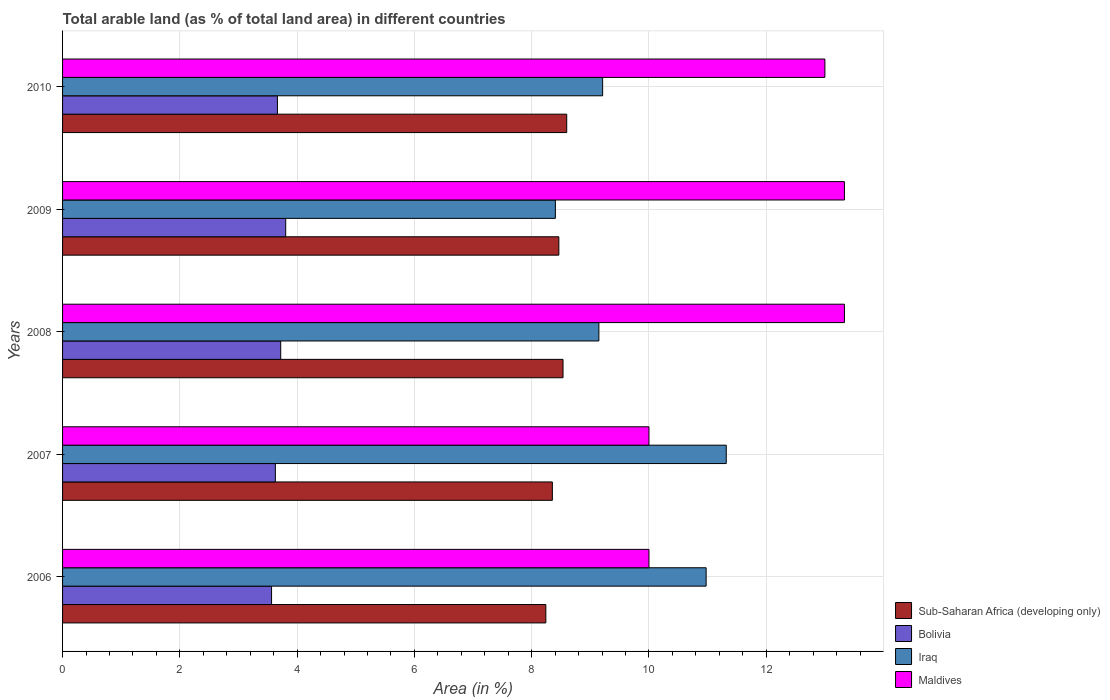How many different coloured bars are there?
Provide a short and direct response. 4. Are the number of bars on each tick of the Y-axis equal?
Make the answer very short. Yes. How many bars are there on the 2nd tick from the bottom?
Your answer should be very brief. 4. What is the label of the 1st group of bars from the top?
Offer a very short reply. 2010. In how many cases, is the number of bars for a given year not equal to the number of legend labels?
Your answer should be compact. 0. What is the percentage of arable land in Iraq in 2008?
Provide a short and direct response. 9.15. Across all years, what is the maximum percentage of arable land in Bolivia?
Provide a short and direct response. 3.81. Across all years, what is the minimum percentage of arable land in Maldives?
Provide a short and direct response. 10. In which year was the percentage of arable land in Sub-Saharan Africa (developing only) maximum?
Offer a very short reply. 2010. In which year was the percentage of arable land in Maldives minimum?
Give a very brief answer. 2006. What is the total percentage of arable land in Maldives in the graph?
Your answer should be compact. 59.67. What is the difference between the percentage of arable land in Iraq in 2009 and that in 2010?
Give a very brief answer. -0.81. What is the difference between the percentage of arable land in Maldives in 2006 and the percentage of arable land in Sub-Saharan Africa (developing only) in 2010?
Your answer should be very brief. 1.4. What is the average percentage of arable land in Iraq per year?
Offer a very short reply. 9.81. In the year 2007, what is the difference between the percentage of arable land in Maldives and percentage of arable land in Iraq?
Your response must be concise. -1.32. In how many years, is the percentage of arable land in Bolivia greater than 3.2 %?
Your answer should be very brief. 5. What is the ratio of the percentage of arable land in Iraq in 2006 to that in 2010?
Provide a succinct answer. 1.19. Is the percentage of arable land in Maldives in 2006 less than that in 2008?
Give a very brief answer. Yes. Is the difference between the percentage of arable land in Maldives in 2009 and 2010 greater than the difference between the percentage of arable land in Iraq in 2009 and 2010?
Your answer should be compact. Yes. What is the difference between the highest and the lowest percentage of arable land in Maldives?
Offer a very short reply. 3.33. In how many years, is the percentage of arable land in Bolivia greater than the average percentage of arable land in Bolivia taken over all years?
Keep it short and to the point. 2. Is it the case that in every year, the sum of the percentage of arable land in Bolivia and percentage of arable land in Sub-Saharan Africa (developing only) is greater than the sum of percentage of arable land in Maldives and percentage of arable land in Iraq?
Provide a short and direct response. No. What does the 3rd bar from the top in 2006 represents?
Offer a very short reply. Bolivia. What does the 4th bar from the bottom in 2008 represents?
Your answer should be compact. Maldives. How many years are there in the graph?
Your answer should be very brief. 5. What is the difference between two consecutive major ticks on the X-axis?
Offer a very short reply. 2. Are the values on the major ticks of X-axis written in scientific E-notation?
Give a very brief answer. No. Does the graph contain grids?
Provide a short and direct response. Yes. How many legend labels are there?
Ensure brevity in your answer.  4. What is the title of the graph?
Your answer should be very brief. Total arable land (as % of total land area) in different countries. Does "Djibouti" appear as one of the legend labels in the graph?
Give a very brief answer. No. What is the label or title of the X-axis?
Make the answer very short. Area (in %). What is the Area (in %) of Sub-Saharan Africa (developing only) in 2006?
Your response must be concise. 8.24. What is the Area (in %) of Bolivia in 2006?
Ensure brevity in your answer.  3.56. What is the Area (in %) in Iraq in 2006?
Make the answer very short. 10.97. What is the Area (in %) of Sub-Saharan Africa (developing only) in 2007?
Your answer should be very brief. 8.35. What is the Area (in %) of Bolivia in 2007?
Your response must be concise. 3.63. What is the Area (in %) of Iraq in 2007?
Give a very brief answer. 11.32. What is the Area (in %) of Maldives in 2007?
Ensure brevity in your answer.  10. What is the Area (in %) of Sub-Saharan Africa (developing only) in 2008?
Provide a short and direct response. 8.53. What is the Area (in %) of Bolivia in 2008?
Offer a very short reply. 3.72. What is the Area (in %) of Iraq in 2008?
Your response must be concise. 9.15. What is the Area (in %) in Maldives in 2008?
Offer a terse response. 13.33. What is the Area (in %) of Sub-Saharan Africa (developing only) in 2009?
Make the answer very short. 8.46. What is the Area (in %) in Bolivia in 2009?
Keep it short and to the point. 3.81. What is the Area (in %) in Iraq in 2009?
Give a very brief answer. 8.4. What is the Area (in %) in Maldives in 2009?
Make the answer very short. 13.33. What is the Area (in %) in Sub-Saharan Africa (developing only) in 2010?
Your answer should be compact. 8.6. What is the Area (in %) in Bolivia in 2010?
Provide a short and direct response. 3.66. What is the Area (in %) of Iraq in 2010?
Make the answer very short. 9.21. What is the Area (in %) in Maldives in 2010?
Keep it short and to the point. 13. Across all years, what is the maximum Area (in %) in Sub-Saharan Africa (developing only)?
Make the answer very short. 8.6. Across all years, what is the maximum Area (in %) in Bolivia?
Your answer should be very brief. 3.81. Across all years, what is the maximum Area (in %) in Iraq?
Make the answer very short. 11.32. Across all years, what is the maximum Area (in %) in Maldives?
Provide a short and direct response. 13.33. Across all years, what is the minimum Area (in %) in Sub-Saharan Africa (developing only)?
Offer a very short reply. 8.24. Across all years, what is the minimum Area (in %) in Bolivia?
Make the answer very short. 3.56. Across all years, what is the minimum Area (in %) of Iraq?
Provide a succinct answer. 8.4. Across all years, what is the minimum Area (in %) in Maldives?
Your answer should be compact. 10. What is the total Area (in %) in Sub-Saharan Africa (developing only) in the graph?
Your answer should be compact. 42.19. What is the total Area (in %) of Bolivia in the graph?
Make the answer very short. 18.38. What is the total Area (in %) in Iraq in the graph?
Your answer should be compact. 49.05. What is the total Area (in %) in Maldives in the graph?
Provide a succinct answer. 59.67. What is the difference between the Area (in %) in Sub-Saharan Africa (developing only) in 2006 and that in 2007?
Ensure brevity in your answer.  -0.11. What is the difference between the Area (in %) of Bolivia in 2006 and that in 2007?
Offer a very short reply. -0.06. What is the difference between the Area (in %) of Iraq in 2006 and that in 2007?
Keep it short and to the point. -0.34. What is the difference between the Area (in %) in Sub-Saharan Africa (developing only) in 2006 and that in 2008?
Keep it short and to the point. -0.29. What is the difference between the Area (in %) in Bolivia in 2006 and that in 2008?
Offer a very short reply. -0.16. What is the difference between the Area (in %) in Iraq in 2006 and that in 2008?
Your response must be concise. 1.83. What is the difference between the Area (in %) of Sub-Saharan Africa (developing only) in 2006 and that in 2009?
Make the answer very short. -0.22. What is the difference between the Area (in %) of Bolivia in 2006 and that in 2009?
Your response must be concise. -0.24. What is the difference between the Area (in %) in Iraq in 2006 and that in 2009?
Keep it short and to the point. 2.57. What is the difference between the Area (in %) of Maldives in 2006 and that in 2009?
Your response must be concise. -3.33. What is the difference between the Area (in %) of Sub-Saharan Africa (developing only) in 2006 and that in 2010?
Offer a very short reply. -0.36. What is the difference between the Area (in %) in Bolivia in 2006 and that in 2010?
Your response must be concise. -0.1. What is the difference between the Area (in %) of Iraq in 2006 and that in 2010?
Give a very brief answer. 1.76. What is the difference between the Area (in %) of Maldives in 2006 and that in 2010?
Offer a very short reply. -3. What is the difference between the Area (in %) in Sub-Saharan Africa (developing only) in 2007 and that in 2008?
Offer a very short reply. -0.18. What is the difference between the Area (in %) in Bolivia in 2007 and that in 2008?
Provide a short and direct response. -0.09. What is the difference between the Area (in %) in Iraq in 2007 and that in 2008?
Your answer should be compact. 2.17. What is the difference between the Area (in %) in Maldives in 2007 and that in 2008?
Offer a terse response. -3.33. What is the difference between the Area (in %) in Sub-Saharan Africa (developing only) in 2007 and that in 2009?
Provide a succinct answer. -0.11. What is the difference between the Area (in %) in Bolivia in 2007 and that in 2009?
Your answer should be very brief. -0.18. What is the difference between the Area (in %) of Iraq in 2007 and that in 2009?
Keep it short and to the point. 2.91. What is the difference between the Area (in %) of Sub-Saharan Africa (developing only) in 2007 and that in 2010?
Provide a short and direct response. -0.24. What is the difference between the Area (in %) in Bolivia in 2007 and that in 2010?
Keep it short and to the point. -0.04. What is the difference between the Area (in %) of Iraq in 2007 and that in 2010?
Ensure brevity in your answer.  2.11. What is the difference between the Area (in %) of Sub-Saharan Africa (developing only) in 2008 and that in 2009?
Ensure brevity in your answer.  0.07. What is the difference between the Area (in %) of Bolivia in 2008 and that in 2009?
Provide a succinct answer. -0.08. What is the difference between the Area (in %) of Iraq in 2008 and that in 2009?
Your answer should be very brief. 0.74. What is the difference between the Area (in %) of Sub-Saharan Africa (developing only) in 2008 and that in 2010?
Offer a terse response. -0.06. What is the difference between the Area (in %) of Bolivia in 2008 and that in 2010?
Offer a terse response. 0.06. What is the difference between the Area (in %) of Iraq in 2008 and that in 2010?
Offer a very short reply. -0.06. What is the difference between the Area (in %) of Sub-Saharan Africa (developing only) in 2009 and that in 2010?
Ensure brevity in your answer.  -0.13. What is the difference between the Area (in %) of Bolivia in 2009 and that in 2010?
Keep it short and to the point. 0.14. What is the difference between the Area (in %) of Iraq in 2009 and that in 2010?
Offer a very short reply. -0.81. What is the difference between the Area (in %) of Maldives in 2009 and that in 2010?
Provide a succinct answer. 0.33. What is the difference between the Area (in %) in Sub-Saharan Africa (developing only) in 2006 and the Area (in %) in Bolivia in 2007?
Provide a short and direct response. 4.61. What is the difference between the Area (in %) in Sub-Saharan Africa (developing only) in 2006 and the Area (in %) in Iraq in 2007?
Provide a succinct answer. -3.08. What is the difference between the Area (in %) of Sub-Saharan Africa (developing only) in 2006 and the Area (in %) of Maldives in 2007?
Your answer should be very brief. -1.76. What is the difference between the Area (in %) in Bolivia in 2006 and the Area (in %) in Iraq in 2007?
Ensure brevity in your answer.  -7.75. What is the difference between the Area (in %) in Bolivia in 2006 and the Area (in %) in Maldives in 2007?
Offer a terse response. -6.44. What is the difference between the Area (in %) in Iraq in 2006 and the Area (in %) in Maldives in 2007?
Keep it short and to the point. 0.97. What is the difference between the Area (in %) in Sub-Saharan Africa (developing only) in 2006 and the Area (in %) in Bolivia in 2008?
Your answer should be compact. 4.52. What is the difference between the Area (in %) of Sub-Saharan Africa (developing only) in 2006 and the Area (in %) of Iraq in 2008?
Offer a terse response. -0.9. What is the difference between the Area (in %) of Sub-Saharan Africa (developing only) in 2006 and the Area (in %) of Maldives in 2008?
Offer a very short reply. -5.09. What is the difference between the Area (in %) in Bolivia in 2006 and the Area (in %) in Iraq in 2008?
Offer a very short reply. -5.58. What is the difference between the Area (in %) in Bolivia in 2006 and the Area (in %) in Maldives in 2008?
Provide a short and direct response. -9.77. What is the difference between the Area (in %) of Iraq in 2006 and the Area (in %) of Maldives in 2008?
Offer a very short reply. -2.36. What is the difference between the Area (in %) of Sub-Saharan Africa (developing only) in 2006 and the Area (in %) of Bolivia in 2009?
Your response must be concise. 4.44. What is the difference between the Area (in %) in Sub-Saharan Africa (developing only) in 2006 and the Area (in %) in Iraq in 2009?
Your answer should be compact. -0.16. What is the difference between the Area (in %) of Sub-Saharan Africa (developing only) in 2006 and the Area (in %) of Maldives in 2009?
Keep it short and to the point. -5.09. What is the difference between the Area (in %) in Bolivia in 2006 and the Area (in %) in Iraq in 2009?
Ensure brevity in your answer.  -4.84. What is the difference between the Area (in %) of Bolivia in 2006 and the Area (in %) of Maldives in 2009?
Keep it short and to the point. -9.77. What is the difference between the Area (in %) of Iraq in 2006 and the Area (in %) of Maldives in 2009?
Your answer should be compact. -2.36. What is the difference between the Area (in %) in Sub-Saharan Africa (developing only) in 2006 and the Area (in %) in Bolivia in 2010?
Provide a succinct answer. 4.58. What is the difference between the Area (in %) of Sub-Saharan Africa (developing only) in 2006 and the Area (in %) of Iraq in 2010?
Keep it short and to the point. -0.97. What is the difference between the Area (in %) of Sub-Saharan Africa (developing only) in 2006 and the Area (in %) of Maldives in 2010?
Make the answer very short. -4.76. What is the difference between the Area (in %) in Bolivia in 2006 and the Area (in %) in Iraq in 2010?
Your response must be concise. -5.65. What is the difference between the Area (in %) of Bolivia in 2006 and the Area (in %) of Maldives in 2010?
Your answer should be very brief. -9.44. What is the difference between the Area (in %) in Iraq in 2006 and the Area (in %) in Maldives in 2010?
Your response must be concise. -2.03. What is the difference between the Area (in %) of Sub-Saharan Africa (developing only) in 2007 and the Area (in %) of Bolivia in 2008?
Your answer should be very brief. 4.63. What is the difference between the Area (in %) of Sub-Saharan Africa (developing only) in 2007 and the Area (in %) of Iraq in 2008?
Ensure brevity in your answer.  -0.79. What is the difference between the Area (in %) of Sub-Saharan Africa (developing only) in 2007 and the Area (in %) of Maldives in 2008?
Offer a terse response. -4.98. What is the difference between the Area (in %) in Bolivia in 2007 and the Area (in %) in Iraq in 2008?
Give a very brief answer. -5.52. What is the difference between the Area (in %) of Bolivia in 2007 and the Area (in %) of Maldives in 2008?
Provide a succinct answer. -9.7. What is the difference between the Area (in %) in Iraq in 2007 and the Area (in %) in Maldives in 2008?
Your answer should be compact. -2.02. What is the difference between the Area (in %) of Sub-Saharan Africa (developing only) in 2007 and the Area (in %) of Bolivia in 2009?
Ensure brevity in your answer.  4.55. What is the difference between the Area (in %) in Sub-Saharan Africa (developing only) in 2007 and the Area (in %) in Iraq in 2009?
Ensure brevity in your answer.  -0.05. What is the difference between the Area (in %) of Sub-Saharan Africa (developing only) in 2007 and the Area (in %) of Maldives in 2009?
Keep it short and to the point. -4.98. What is the difference between the Area (in %) in Bolivia in 2007 and the Area (in %) in Iraq in 2009?
Provide a succinct answer. -4.78. What is the difference between the Area (in %) of Bolivia in 2007 and the Area (in %) of Maldives in 2009?
Your answer should be very brief. -9.7. What is the difference between the Area (in %) of Iraq in 2007 and the Area (in %) of Maldives in 2009?
Keep it short and to the point. -2.02. What is the difference between the Area (in %) of Sub-Saharan Africa (developing only) in 2007 and the Area (in %) of Bolivia in 2010?
Your answer should be very brief. 4.69. What is the difference between the Area (in %) in Sub-Saharan Africa (developing only) in 2007 and the Area (in %) in Iraq in 2010?
Ensure brevity in your answer.  -0.86. What is the difference between the Area (in %) in Sub-Saharan Africa (developing only) in 2007 and the Area (in %) in Maldives in 2010?
Provide a succinct answer. -4.65. What is the difference between the Area (in %) of Bolivia in 2007 and the Area (in %) of Iraq in 2010?
Your response must be concise. -5.58. What is the difference between the Area (in %) of Bolivia in 2007 and the Area (in %) of Maldives in 2010?
Your answer should be very brief. -9.37. What is the difference between the Area (in %) in Iraq in 2007 and the Area (in %) in Maldives in 2010?
Your answer should be very brief. -1.68. What is the difference between the Area (in %) in Sub-Saharan Africa (developing only) in 2008 and the Area (in %) in Bolivia in 2009?
Offer a terse response. 4.73. What is the difference between the Area (in %) in Sub-Saharan Africa (developing only) in 2008 and the Area (in %) in Iraq in 2009?
Your answer should be compact. 0.13. What is the difference between the Area (in %) of Sub-Saharan Africa (developing only) in 2008 and the Area (in %) of Maldives in 2009?
Your answer should be very brief. -4.8. What is the difference between the Area (in %) of Bolivia in 2008 and the Area (in %) of Iraq in 2009?
Your answer should be compact. -4.68. What is the difference between the Area (in %) in Bolivia in 2008 and the Area (in %) in Maldives in 2009?
Offer a terse response. -9.61. What is the difference between the Area (in %) in Iraq in 2008 and the Area (in %) in Maldives in 2009?
Offer a terse response. -4.19. What is the difference between the Area (in %) in Sub-Saharan Africa (developing only) in 2008 and the Area (in %) in Bolivia in 2010?
Keep it short and to the point. 4.87. What is the difference between the Area (in %) of Sub-Saharan Africa (developing only) in 2008 and the Area (in %) of Iraq in 2010?
Offer a terse response. -0.68. What is the difference between the Area (in %) of Sub-Saharan Africa (developing only) in 2008 and the Area (in %) of Maldives in 2010?
Provide a succinct answer. -4.47. What is the difference between the Area (in %) in Bolivia in 2008 and the Area (in %) in Iraq in 2010?
Provide a short and direct response. -5.49. What is the difference between the Area (in %) of Bolivia in 2008 and the Area (in %) of Maldives in 2010?
Your response must be concise. -9.28. What is the difference between the Area (in %) of Iraq in 2008 and the Area (in %) of Maldives in 2010?
Provide a succinct answer. -3.85. What is the difference between the Area (in %) in Sub-Saharan Africa (developing only) in 2009 and the Area (in %) in Bolivia in 2010?
Your answer should be very brief. 4.8. What is the difference between the Area (in %) of Sub-Saharan Africa (developing only) in 2009 and the Area (in %) of Iraq in 2010?
Your answer should be very brief. -0.75. What is the difference between the Area (in %) of Sub-Saharan Africa (developing only) in 2009 and the Area (in %) of Maldives in 2010?
Keep it short and to the point. -4.54. What is the difference between the Area (in %) in Bolivia in 2009 and the Area (in %) in Iraq in 2010?
Provide a succinct answer. -5.4. What is the difference between the Area (in %) in Bolivia in 2009 and the Area (in %) in Maldives in 2010?
Keep it short and to the point. -9.2. What is the difference between the Area (in %) in Iraq in 2009 and the Area (in %) in Maldives in 2010?
Keep it short and to the point. -4.6. What is the average Area (in %) of Sub-Saharan Africa (developing only) per year?
Give a very brief answer. 8.44. What is the average Area (in %) of Bolivia per year?
Ensure brevity in your answer.  3.68. What is the average Area (in %) in Iraq per year?
Provide a succinct answer. 9.81. What is the average Area (in %) in Maldives per year?
Offer a very short reply. 11.93. In the year 2006, what is the difference between the Area (in %) in Sub-Saharan Africa (developing only) and Area (in %) in Bolivia?
Provide a succinct answer. 4.68. In the year 2006, what is the difference between the Area (in %) of Sub-Saharan Africa (developing only) and Area (in %) of Iraq?
Your answer should be compact. -2.73. In the year 2006, what is the difference between the Area (in %) of Sub-Saharan Africa (developing only) and Area (in %) of Maldives?
Your answer should be compact. -1.76. In the year 2006, what is the difference between the Area (in %) of Bolivia and Area (in %) of Iraq?
Your answer should be compact. -7.41. In the year 2006, what is the difference between the Area (in %) in Bolivia and Area (in %) in Maldives?
Offer a very short reply. -6.44. In the year 2006, what is the difference between the Area (in %) of Iraq and Area (in %) of Maldives?
Your answer should be very brief. 0.97. In the year 2007, what is the difference between the Area (in %) in Sub-Saharan Africa (developing only) and Area (in %) in Bolivia?
Provide a succinct answer. 4.72. In the year 2007, what is the difference between the Area (in %) in Sub-Saharan Africa (developing only) and Area (in %) in Iraq?
Provide a succinct answer. -2.97. In the year 2007, what is the difference between the Area (in %) in Sub-Saharan Africa (developing only) and Area (in %) in Maldives?
Your answer should be very brief. -1.65. In the year 2007, what is the difference between the Area (in %) in Bolivia and Area (in %) in Iraq?
Ensure brevity in your answer.  -7.69. In the year 2007, what is the difference between the Area (in %) in Bolivia and Area (in %) in Maldives?
Your response must be concise. -6.37. In the year 2007, what is the difference between the Area (in %) of Iraq and Area (in %) of Maldives?
Offer a terse response. 1.32. In the year 2008, what is the difference between the Area (in %) of Sub-Saharan Africa (developing only) and Area (in %) of Bolivia?
Your answer should be compact. 4.81. In the year 2008, what is the difference between the Area (in %) in Sub-Saharan Africa (developing only) and Area (in %) in Iraq?
Your response must be concise. -0.61. In the year 2008, what is the difference between the Area (in %) in Sub-Saharan Africa (developing only) and Area (in %) in Maldives?
Your response must be concise. -4.8. In the year 2008, what is the difference between the Area (in %) of Bolivia and Area (in %) of Iraq?
Make the answer very short. -5.43. In the year 2008, what is the difference between the Area (in %) of Bolivia and Area (in %) of Maldives?
Your answer should be compact. -9.61. In the year 2008, what is the difference between the Area (in %) in Iraq and Area (in %) in Maldives?
Your response must be concise. -4.19. In the year 2009, what is the difference between the Area (in %) of Sub-Saharan Africa (developing only) and Area (in %) of Bolivia?
Ensure brevity in your answer.  4.66. In the year 2009, what is the difference between the Area (in %) in Sub-Saharan Africa (developing only) and Area (in %) in Iraq?
Provide a succinct answer. 0.06. In the year 2009, what is the difference between the Area (in %) of Sub-Saharan Africa (developing only) and Area (in %) of Maldives?
Offer a terse response. -4.87. In the year 2009, what is the difference between the Area (in %) of Bolivia and Area (in %) of Iraq?
Provide a short and direct response. -4.6. In the year 2009, what is the difference between the Area (in %) of Bolivia and Area (in %) of Maldives?
Offer a very short reply. -9.53. In the year 2009, what is the difference between the Area (in %) in Iraq and Area (in %) in Maldives?
Your answer should be very brief. -4.93. In the year 2010, what is the difference between the Area (in %) in Sub-Saharan Africa (developing only) and Area (in %) in Bolivia?
Give a very brief answer. 4.93. In the year 2010, what is the difference between the Area (in %) in Sub-Saharan Africa (developing only) and Area (in %) in Iraq?
Provide a short and direct response. -0.61. In the year 2010, what is the difference between the Area (in %) in Sub-Saharan Africa (developing only) and Area (in %) in Maldives?
Your response must be concise. -4.4. In the year 2010, what is the difference between the Area (in %) of Bolivia and Area (in %) of Iraq?
Keep it short and to the point. -5.55. In the year 2010, what is the difference between the Area (in %) in Bolivia and Area (in %) in Maldives?
Keep it short and to the point. -9.34. In the year 2010, what is the difference between the Area (in %) in Iraq and Area (in %) in Maldives?
Provide a short and direct response. -3.79. What is the ratio of the Area (in %) in Sub-Saharan Africa (developing only) in 2006 to that in 2007?
Give a very brief answer. 0.99. What is the ratio of the Area (in %) of Bolivia in 2006 to that in 2007?
Offer a terse response. 0.98. What is the ratio of the Area (in %) in Iraq in 2006 to that in 2007?
Provide a succinct answer. 0.97. What is the ratio of the Area (in %) of Maldives in 2006 to that in 2007?
Ensure brevity in your answer.  1. What is the ratio of the Area (in %) in Sub-Saharan Africa (developing only) in 2006 to that in 2008?
Ensure brevity in your answer.  0.97. What is the ratio of the Area (in %) in Bolivia in 2006 to that in 2008?
Give a very brief answer. 0.96. What is the ratio of the Area (in %) of Iraq in 2006 to that in 2008?
Provide a short and direct response. 1.2. What is the ratio of the Area (in %) in Sub-Saharan Africa (developing only) in 2006 to that in 2009?
Offer a very short reply. 0.97. What is the ratio of the Area (in %) of Bolivia in 2006 to that in 2009?
Provide a short and direct response. 0.94. What is the ratio of the Area (in %) in Iraq in 2006 to that in 2009?
Provide a short and direct response. 1.31. What is the ratio of the Area (in %) of Maldives in 2006 to that in 2009?
Your response must be concise. 0.75. What is the ratio of the Area (in %) of Sub-Saharan Africa (developing only) in 2006 to that in 2010?
Your answer should be compact. 0.96. What is the ratio of the Area (in %) of Bolivia in 2006 to that in 2010?
Provide a short and direct response. 0.97. What is the ratio of the Area (in %) of Iraq in 2006 to that in 2010?
Your response must be concise. 1.19. What is the ratio of the Area (in %) in Maldives in 2006 to that in 2010?
Provide a succinct answer. 0.77. What is the ratio of the Area (in %) in Sub-Saharan Africa (developing only) in 2007 to that in 2008?
Give a very brief answer. 0.98. What is the ratio of the Area (in %) in Bolivia in 2007 to that in 2008?
Make the answer very short. 0.98. What is the ratio of the Area (in %) in Iraq in 2007 to that in 2008?
Your answer should be compact. 1.24. What is the ratio of the Area (in %) in Sub-Saharan Africa (developing only) in 2007 to that in 2009?
Give a very brief answer. 0.99. What is the ratio of the Area (in %) in Bolivia in 2007 to that in 2009?
Your answer should be compact. 0.95. What is the ratio of the Area (in %) of Iraq in 2007 to that in 2009?
Provide a succinct answer. 1.35. What is the ratio of the Area (in %) of Maldives in 2007 to that in 2009?
Offer a very short reply. 0.75. What is the ratio of the Area (in %) of Sub-Saharan Africa (developing only) in 2007 to that in 2010?
Make the answer very short. 0.97. What is the ratio of the Area (in %) in Iraq in 2007 to that in 2010?
Offer a terse response. 1.23. What is the ratio of the Area (in %) of Maldives in 2007 to that in 2010?
Offer a very short reply. 0.77. What is the ratio of the Area (in %) of Sub-Saharan Africa (developing only) in 2008 to that in 2009?
Make the answer very short. 1.01. What is the ratio of the Area (in %) in Bolivia in 2008 to that in 2009?
Provide a succinct answer. 0.98. What is the ratio of the Area (in %) of Iraq in 2008 to that in 2009?
Offer a terse response. 1.09. What is the ratio of the Area (in %) in Sub-Saharan Africa (developing only) in 2008 to that in 2010?
Your answer should be compact. 0.99. What is the ratio of the Area (in %) of Bolivia in 2008 to that in 2010?
Make the answer very short. 1.02. What is the ratio of the Area (in %) in Maldives in 2008 to that in 2010?
Your answer should be compact. 1.03. What is the ratio of the Area (in %) in Sub-Saharan Africa (developing only) in 2009 to that in 2010?
Make the answer very short. 0.98. What is the ratio of the Area (in %) of Bolivia in 2009 to that in 2010?
Your answer should be compact. 1.04. What is the ratio of the Area (in %) of Iraq in 2009 to that in 2010?
Give a very brief answer. 0.91. What is the ratio of the Area (in %) of Maldives in 2009 to that in 2010?
Make the answer very short. 1.03. What is the difference between the highest and the second highest Area (in %) in Sub-Saharan Africa (developing only)?
Your response must be concise. 0.06. What is the difference between the highest and the second highest Area (in %) of Bolivia?
Offer a terse response. 0.08. What is the difference between the highest and the second highest Area (in %) of Iraq?
Your response must be concise. 0.34. What is the difference between the highest and the lowest Area (in %) in Sub-Saharan Africa (developing only)?
Your response must be concise. 0.36. What is the difference between the highest and the lowest Area (in %) in Bolivia?
Ensure brevity in your answer.  0.24. What is the difference between the highest and the lowest Area (in %) of Iraq?
Provide a succinct answer. 2.91. What is the difference between the highest and the lowest Area (in %) of Maldives?
Keep it short and to the point. 3.33. 